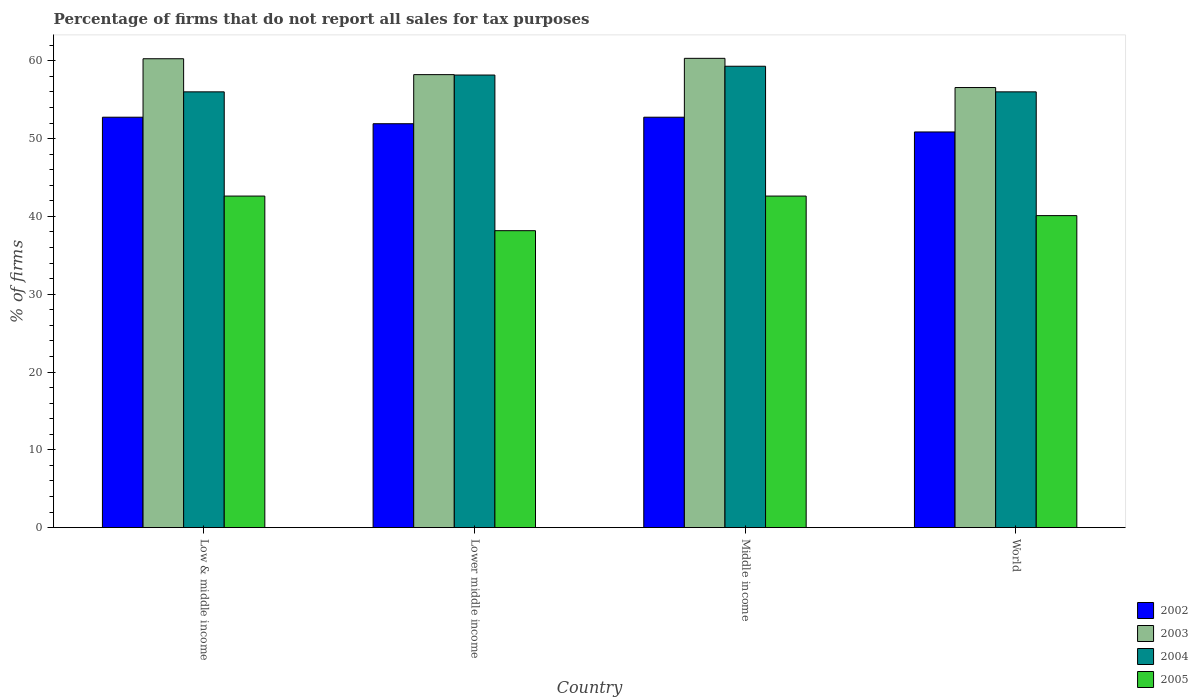How many bars are there on the 3rd tick from the left?
Your response must be concise. 4. What is the label of the 1st group of bars from the left?
Your answer should be compact. Low & middle income. What is the percentage of firms that do not report all sales for tax purposes in 2005 in Middle income?
Your answer should be compact. 42.61. Across all countries, what is the maximum percentage of firms that do not report all sales for tax purposes in 2005?
Ensure brevity in your answer.  42.61. Across all countries, what is the minimum percentage of firms that do not report all sales for tax purposes in 2003?
Ensure brevity in your answer.  56.56. In which country was the percentage of firms that do not report all sales for tax purposes in 2003 maximum?
Your answer should be very brief. Middle income. What is the total percentage of firms that do not report all sales for tax purposes in 2004 in the graph?
Provide a succinct answer. 229.47. What is the difference between the percentage of firms that do not report all sales for tax purposes in 2002 in Low & middle income and that in Lower middle income?
Provide a short and direct response. 0.84. What is the difference between the percentage of firms that do not report all sales for tax purposes in 2002 in Lower middle income and the percentage of firms that do not report all sales for tax purposes in 2005 in Low & middle income?
Your response must be concise. 9.3. What is the average percentage of firms that do not report all sales for tax purposes in 2003 per country?
Provide a succinct answer. 58.84. What is the difference between the percentage of firms that do not report all sales for tax purposes of/in 2002 and percentage of firms that do not report all sales for tax purposes of/in 2004 in Lower middle income?
Make the answer very short. -6.26. In how many countries, is the percentage of firms that do not report all sales for tax purposes in 2003 greater than 40 %?
Give a very brief answer. 4. What is the ratio of the percentage of firms that do not report all sales for tax purposes in 2005 in Low & middle income to that in World?
Provide a succinct answer. 1.06. Is the percentage of firms that do not report all sales for tax purposes in 2002 in Lower middle income less than that in World?
Provide a short and direct response. No. Is the difference between the percentage of firms that do not report all sales for tax purposes in 2002 in Middle income and World greater than the difference between the percentage of firms that do not report all sales for tax purposes in 2004 in Middle income and World?
Provide a short and direct response. No. What is the difference between the highest and the second highest percentage of firms that do not report all sales for tax purposes in 2005?
Provide a short and direct response. -2.51. What is the difference between the highest and the lowest percentage of firms that do not report all sales for tax purposes in 2003?
Make the answer very short. 3.75. In how many countries, is the percentage of firms that do not report all sales for tax purposes in 2004 greater than the average percentage of firms that do not report all sales for tax purposes in 2004 taken over all countries?
Provide a short and direct response. 2. Is the sum of the percentage of firms that do not report all sales for tax purposes in 2005 in Low & middle income and World greater than the maximum percentage of firms that do not report all sales for tax purposes in 2002 across all countries?
Your response must be concise. Yes. Is it the case that in every country, the sum of the percentage of firms that do not report all sales for tax purposes in 2005 and percentage of firms that do not report all sales for tax purposes in 2004 is greater than the percentage of firms that do not report all sales for tax purposes in 2003?
Your answer should be very brief. Yes. How many bars are there?
Your answer should be compact. 16. Are all the bars in the graph horizontal?
Provide a short and direct response. No. How many countries are there in the graph?
Your answer should be very brief. 4. What is the difference between two consecutive major ticks on the Y-axis?
Provide a short and direct response. 10. Are the values on the major ticks of Y-axis written in scientific E-notation?
Make the answer very short. No. Does the graph contain any zero values?
Give a very brief answer. No. Does the graph contain grids?
Provide a short and direct response. No. Where does the legend appear in the graph?
Your response must be concise. Bottom right. How many legend labels are there?
Make the answer very short. 4. How are the legend labels stacked?
Offer a very short reply. Vertical. What is the title of the graph?
Give a very brief answer. Percentage of firms that do not report all sales for tax purposes. Does "2004" appear as one of the legend labels in the graph?
Offer a very short reply. Yes. What is the label or title of the X-axis?
Offer a very short reply. Country. What is the label or title of the Y-axis?
Your answer should be very brief. % of firms. What is the % of firms in 2002 in Low & middle income?
Make the answer very short. 52.75. What is the % of firms of 2003 in Low & middle income?
Keep it short and to the point. 60.26. What is the % of firms in 2004 in Low & middle income?
Your answer should be very brief. 56.01. What is the % of firms in 2005 in Low & middle income?
Ensure brevity in your answer.  42.61. What is the % of firms of 2002 in Lower middle income?
Offer a terse response. 51.91. What is the % of firms in 2003 in Lower middle income?
Give a very brief answer. 58.22. What is the % of firms in 2004 in Lower middle income?
Provide a short and direct response. 58.16. What is the % of firms of 2005 in Lower middle income?
Offer a very short reply. 38.16. What is the % of firms in 2002 in Middle income?
Your answer should be very brief. 52.75. What is the % of firms in 2003 in Middle income?
Provide a succinct answer. 60.31. What is the % of firms of 2004 in Middle income?
Offer a very short reply. 59.3. What is the % of firms in 2005 in Middle income?
Make the answer very short. 42.61. What is the % of firms in 2002 in World?
Offer a terse response. 50.85. What is the % of firms of 2003 in World?
Offer a very short reply. 56.56. What is the % of firms in 2004 in World?
Make the answer very short. 56.01. What is the % of firms in 2005 in World?
Make the answer very short. 40.1. Across all countries, what is the maximum % of firms in 2002?
Your response must be concise. 52.75. Across all countries, what is the maximum % of firms of 2003?
Offer a very short reply. 60.31. Across all countries, what is the maximum % of firms of 2004?
Offer a very short reply. 59.3. Across all countries, what is the maximum % of firms of 2005?
Offer a terse response. 42.61. Across all countries, what is the minimum % of firms in 2002?
Make the answer very short. 50.85. Across all countries, what is the minimum % of firms of 2003?
Offer a terse response. 56.56. Across all countries, what is the minimum % of firms of 2004?
Your response must be concise. 56.01. Across all countries, what is the minimum % of firms of 2005?
Make the answer very short. 38.16. What is the total % of firms in 2002 in the graph?
Your answer should be very brief. 208.25. What is the total % of firms of 2003 in the graph?
Ensure brevity in your answer.  235.35. What is the total % of firms of 2004 in the graph?
Your answer should be very brief. 229.47. What is the total % of firms of 2005 in the graph?
Offer a very short reply. 163.48. What is the difference between the % of firms in 2002 in Low & middle income and that in Lower middle income?
Keep it short and to the point. 0.84. What is the difference between the % of firms in 2003 in Low & middle income and that in Lower middle income?
Your answer should be very brief. 2.04. What is the difference between the % of firms of 2004 in Low & middle income and that in Lower middle income?
Your answer should be compact. -2.16. What is the difference between the % of firms in 2005 in Low & middle income and that in Lower middle income?
Provide a succinct answer. 4.45. What is the difference between the % of firms of 2003 in Low & middle income and that in Middle income?
Your answer should be very brief. -0.05. What is the difference between the % of firms of 2004 in Low & middle income and that in Middle income?
Give a very brief answer. -3.29. What is the difference between the % of firms of 2002 in Low & middle income and that in World?
Give a very brief answer. 1.89. What is the difference between the % of firms of 2003 in Low & middle income and that in World?
Make the answer very short. 3.7. What is the difference between the % of firms in 2004 in Low & middle income and that in World?
Your answer should be compact. 0. What is the difference between the % of firms of 2005 in Low & middle income and that in World?
Keep it short and to the point. 2.51. What is the difference between the % of firms of 2002 in Lower middle income and that in Middle income?
Offer a terse response. -0.84. What is the difference between the % of firms of 2003 in Lower middle income and that in Middle income?
Your answer should be compact. -2.09. What is the difference between the % of firms of 2004 in Lower middle income and that in Middle income?
Provide a succinct answer. -1.13. What is the difference between the % of firms in 2005 in Lower middle income and that in Middle income?
Your response must be concise. -4.45. What is the difference between the % of firms in 2002 in Lower middle income and that in World?
Make the answer very short. 1.06. What is the difference between the % of firms of 2003 in Lower middle income and that in World?
Offer a very short reply. 1.66. What is the difference between the % of firms of 2004 in Lower middle income and that in World?
Your answer should be very brief. 2.16. What is the difference between the % of firms in 2005 in Lower middle income and that in World?
Give a very brief answer. -1.94. What is the difference between the % of firms of 2002 in Middle income and that in World?
Ensure brevity in your answer.  1.89. What is the difference between the % of firms of 2003 in Middle income and that in World?
Provide a short and direct response. 3.75. What is the difference between the % of firms of 2004 in Middle income and that in World?
Make the answer very short. 3.29. What is the difference between the % of firms of 2005 in Middle income and that in World?
Ensure brevity in your answer.  2.51. What is the difference between the % of firms of 2002 in Low & middle income and the % of firms of 2003 in Lower middle income?
Offer a terse response. -5.47. What is the difference between the % of firms of 2002 in Low & middle income and the % of firms of 2004 in Lower middle income?
Make the answer very short. -5.42. What is the difference between the % of firms of 2002 in Low & middle income and the % of firms of 2005 in Lower middle income?
Provide a short and direct response. 14.58. What is the difference between the % of firms in 2003 in Low & middle income and the % of firms in 2004 in Lower middle income?
Offer a terse response. 2.1. What is the difference between the % of firms of 2003 in Low & middle income and the % of firms of 2005 in Lower middle income?
Ensure brevity in your answer.  22.1. What is the difference between the % of firms in 2004 in Low & middle income and the % of firms in 2005 in Lower middle income?
Your answer should be compact. 17.84. What is the difference between the % of firms in 2002 in Low & middle income and the % of firms in 2003 in Middle income?
Your answer should be compact. -7.57. What is the difference between the % of firms in 2002 in Low & middle income and the % of firms in 2004 in Middle income?
Provide a short and direct response. -6.55. What is the difference between the % of firms in 2002 in Low & middle income and the % of firms in 2005 in Middle income?
Keep it short and to the point. 10.13. What is the difference between the % of firms in 2003 in Low & middle income and the % of firms in 2004 in Middle income?
Your answer should be compact. 0.96. What is the difference between the % of firms of 2003 in Low & middle income and the % of firms of 2005 in Middle income?
Provide a short and direct response. 17.65. What is the difference between the % of firms of 2004 in Low & middle income and the % of firms of 2005 in Middle income?
Give a very brief answer. 13.39. What is the difference between the % of firms in 2002 in Low & middle income and the % of firms in 2003 in World?
Offer a very short reply. -3.81. What is the difference between the % of firms of 2002 in Low & middle income and the % of firms of 2004 in World?
Keep it short and to the point. -3.26. What is the difference between the % of firms of 2002 in Low & middle income and the % of firms of 2005 in World?
Offer a terse response. 12.65. What is the difference between the % of firms of 2003 in Low & middle income and the % of firms of 2004 in World?
Make the answer very short. 4.25. What is the difference between the % of firms of 2003 in Low & middle income and the % of firms of 2005 in World?
Provide a short and direct response. 20.16. What is the difference between the % of firms of 2004 in Low & middle income and the % of firms of 2005 in World?
Provide a short and direct response. 15.91. What is the difference between the % of firms in 2002 in Lower middle income and the % of firms in 2003 in Middle income?
Provide a succinct answer. -8.4. What is the difference between the % of firms in 2002 in Lower middle income and the % of firms in 2004 in Middle income?
Provide a short and direct response. -7.39. What is the difference between the % of firms in 2002 in Lower middle income and the % of firms in 2005 in Middle income?
Offer a terse response. 9.3. What is the difference between the % of firms of 2003 in Lower middle income and the % of firms of 2004 in Middle income?
Provide a short and direct response. -1.08. What is the difference between the % of firms of 2003 in Lower middle income and the % of firms of 2005 in Middle income?
Your answer should be very brief. 15.61. What is the difference between the % of firms of 2004 in Lower middle income and the % of firms of 2005 in Middle income?
Ensure brevity in your answer.  15.55. What is the difference between the % of firms of 2002 in Lower middle income and the % of firms of 2003 in World?
Offer a terse response. -4.65. What is the difference between the % of firms in 2002 in Lower middle income and the % of firms in 2004 in World?
Provide a succinct answer. -4.1. What is the difference between the % of firms of 2002 in Lower middle income and the % of firms of 2005 in World?
Make the answer very short. 11.81. What is the difference between the % of firms in 2003 in Lower middle income and the % of firms in 2004 in World?
Your answer should be compact. 2.21. What is the difference between the % of firms in 2003 in Lower middle income and the % of firms in 2005 in World?
Your answer should be compact. 18.12. What is the difference between the % of firms of 2004 in Lower middle income and the % of firms of 2005 in World?
Make the answer very short. 18.07. What is the difference between the % of firms of 2002 in Middle income and the % of firms of 2003 in World?
Offer a very short reply. -3.81. What is the difference between the % of firms of 2002 in Middle income and the % of firms of 2004 in World?
Give a very brief answer. -3.26. What is the difference between the % of firms of 2002 in Middle income and the % of firms of 2005 in World?
Offer a terse response. 12.65. What is the difference between the % of firms of 2003 in Middle income and the % of firms of 2004 in World?
Make the answer very short. 4.31. What is the difference between the % of firms of 2003 in Middle income and the % of firms of 2005 in World?
Your answer should be compact. 20.21. What is the difference between the % of firms in 2004 in Middle income and the % of firms in 2005 in World?
Give a very brief answer. 19.2. What is the average % of firms in 2002 per country?
Keep it short and to the point. 52.06. What is the average % of firms of 2003 per country?
Ensure brevity in your answer.  58.84. What is the average % of firms in 2004 per country?
Provide a short and direct response. 57.37. What is the average % of firms in 2005 per country?
Provide a short and direct response. 40.87. What is the difference between the % of firms in 2002 and % of firms in 2003 in Low & middle income?
Make the answer very short. -7.51. What is the difference between the % of firms of 2002 and % of firms of 2004 in Low & middle income?
Your answer should be very brief. -3.26. What is the difference between the % of firms of 2002 and % of firms of 2005 in Low & middle income?
Give a very brief answer. 10.13. What is the difference between the % of firms of 2003 and % of firms of 2004 in Low & middle income?
Make the answer very short. 4.25. What is the difference between the % of firms of 2003 and % of firms of 2005 in Low & middle income?
Provide a short and direct response. 17.65. What is the difference between the % of firms of 2004 and % of firms of 2005 in Low & middle income?
Provide a succinct answer. 13.39. What is the difference between the % of firms in 2002 and % of firms in 2003 in Lower middle income?
Provide a short and direct response. -6.31. What is the difference between the % of firms of 2002 and % of firms of 2004 in Lower middle income?
Offer a very short reply. -6.26. What is the difference between the % of firms of 2002 and % of firms of 2005 in Lower middle income?
Provide a succinct answer. 13.75. What is the difference between the % of firms of 2003 and % of firms of 2004 in Lower middle income?
Offer a terse response. 0.05. What is the difference between the % of firms of 2003 and % of firms of 2005 in Lower middle income?
Your response must be concise. 20.06. What is the difference between the % of firms in 2004 and % of firms in 2005 in Lower middle income?
Give a very brief answer. 20. What is the difference between the % of firms of 2002 and % of firms of 2003 in Middle income?
Offer a very short reply. -7.57. What is the difference between the % of firms of 2002 and % of firms of 2004 in Middle income?
Make the answer very short. -6.55. What is the difference between the % of firms in 2002 and % of firms in 2005 in Middle income?
Provide a succinct answer. 10.13. What is the difference between the % of firms of 2003 and % of firms of 2004 in Middle income?
Provide a short and direct response. 1.02. What is the difference between the % of firms of 2003 and % of firms of 2005 in Middle income?
Provide a succinct answer. 17.7. What is the difference between the % of firms in 2004 and % of firms in 2005 in Middle income?
Your response must be concise. 16.69. What is the difference between the % of firms in 2002 and % of firms in 2003 in World?
Your response must be concise. -5.71. What is the difference between the % of firms in 2002 and % of firms in 2004 in World?
Offer a very short reply. -5.15. What is the difference between the % of firms of 2002 and % of firms of 2005 in World?
Give a very brief answer. 10.75. What is the difference between the % of firms in 2003 and % of firms in 2004 in World?
Your response must be concise. 0.56. What is the difference between the % of firms of 2003 and % of firms of 2005 in World?
Offer a very short reply. 16.46. What is the difference between the % of firms of 2004 and % of firms of 2005 in World?
Your response must be concise. 15.91. What is the ratio of the % of firms of 2002 in Low & middle income to that in Lower middle income?
Provide a succinct answer. 1.02. What is the ratio of the % of firms of 2003 in Low & middle income to that in Lower middle income?
Provide a succinct answer. 1.04. What is the ratio of the % of firms of 2004 in Low & middle income to that in Lower middle income?
Your answer should be compact. 0.96. What is the ratio of the % of firms in 2005 in Low & middle income to that in Lower middle income?
Offer a terse response. 1.12. What is the ratio of the % of firms in 2002 in Low & middle income to that in Middle income?
Your response must be concise. 1. What is the ratio of the % of firms of 2003 in Low & middle income to that in Middle income?
Ensure brevity in your answer.  1. What is the ratio of the % of firms in 2004 in Low & middle income to that in Middle income?
Your answer should be compact. 0.94. What is the ratio of the % of firms of 2005 in Low & middle income to that in Middle income?
Your answer should be very brief. 1. What is the ratio of the % of firms in 2002 in Low & middle income to that in World?
Give a very brief answer. 1.04. What is the ratio of the % of firms of 2003 in Low & middle income to that in World?
Keep it short and to the point. 1.07. What is the ratio of the % of firms in 2005 in Low & middle income to that in World?
Give a very brief answer. 1.06. What is the ratio of the % of firms of 2002 in Lower middle income to that in Middle income?
Provide a short and direct response. 0.98. What is the ratio of the % of firms in 2003 in Lower middle income to that in Middle income?
Offer a very short reply. 0.97. What is the ratio of the % of firms in 2004 in Lower middle income to that in Middle income?
Keep it short and to the point. 0.98. What is the ratio of the % of firms of 2005 in Lower middle income to that in Middle income?
Make the answer very short. 0.9. What is the ratio of the % of firms of 2002 in Lower middle income to that in World?
Ensure brevity in your answer.  1.02. What is the ratio of the % of firms of 2003 in Lower middle income to that in World?
Provide a succinct answer. 1.03. What is the ratio of the % of firms in 2004 in Lower middle income to that in World?
Provide a succinct answer. 1.04. What is the ratio of the % of firms in 2005 in Lower middle income to that in World?
Give a very brief answer. 0.95. What is the ratio of the % of firms of 2002 in Middle income to that in World?
Offer a very short reply. 1.04. What is the ratio of the % of firms in 2003 in Middle income to that in World?
Offer a very short reply. 1.07. What is the ratio of the % of firms of 2004 in Middle income to that in World?
Provide a short and direct response. 1.06. What is the ratio of the % of firms in 2005 in Middle income to that in World?
Your answer should be compact. 1.06. What is the difference between the highest and the second highest % of firms in 2003?
Ensure brevity in your answer.  0.05. What is the difference between the highest and the second highest % of firms in 2004?
Your answer should be very brief. 1.13. What is the difference between the highest and the second highest % of firms in 2005?
Offer a very short reply. 0. What is the difference between the highest and the lowest % of firms of 2002?
Provide a short and direct response. 1.89. What is the difference between the highest and the lowest % of firms in 2003?
Offer a terse response. 3.75. What is the difference between the highest and the lowest % of firms in 2004?
Offer a very short reply. 3.29. What is the difference between the highest and the lowest % of firms of 2005?
Ensure brevity in your answer.  4.45. 